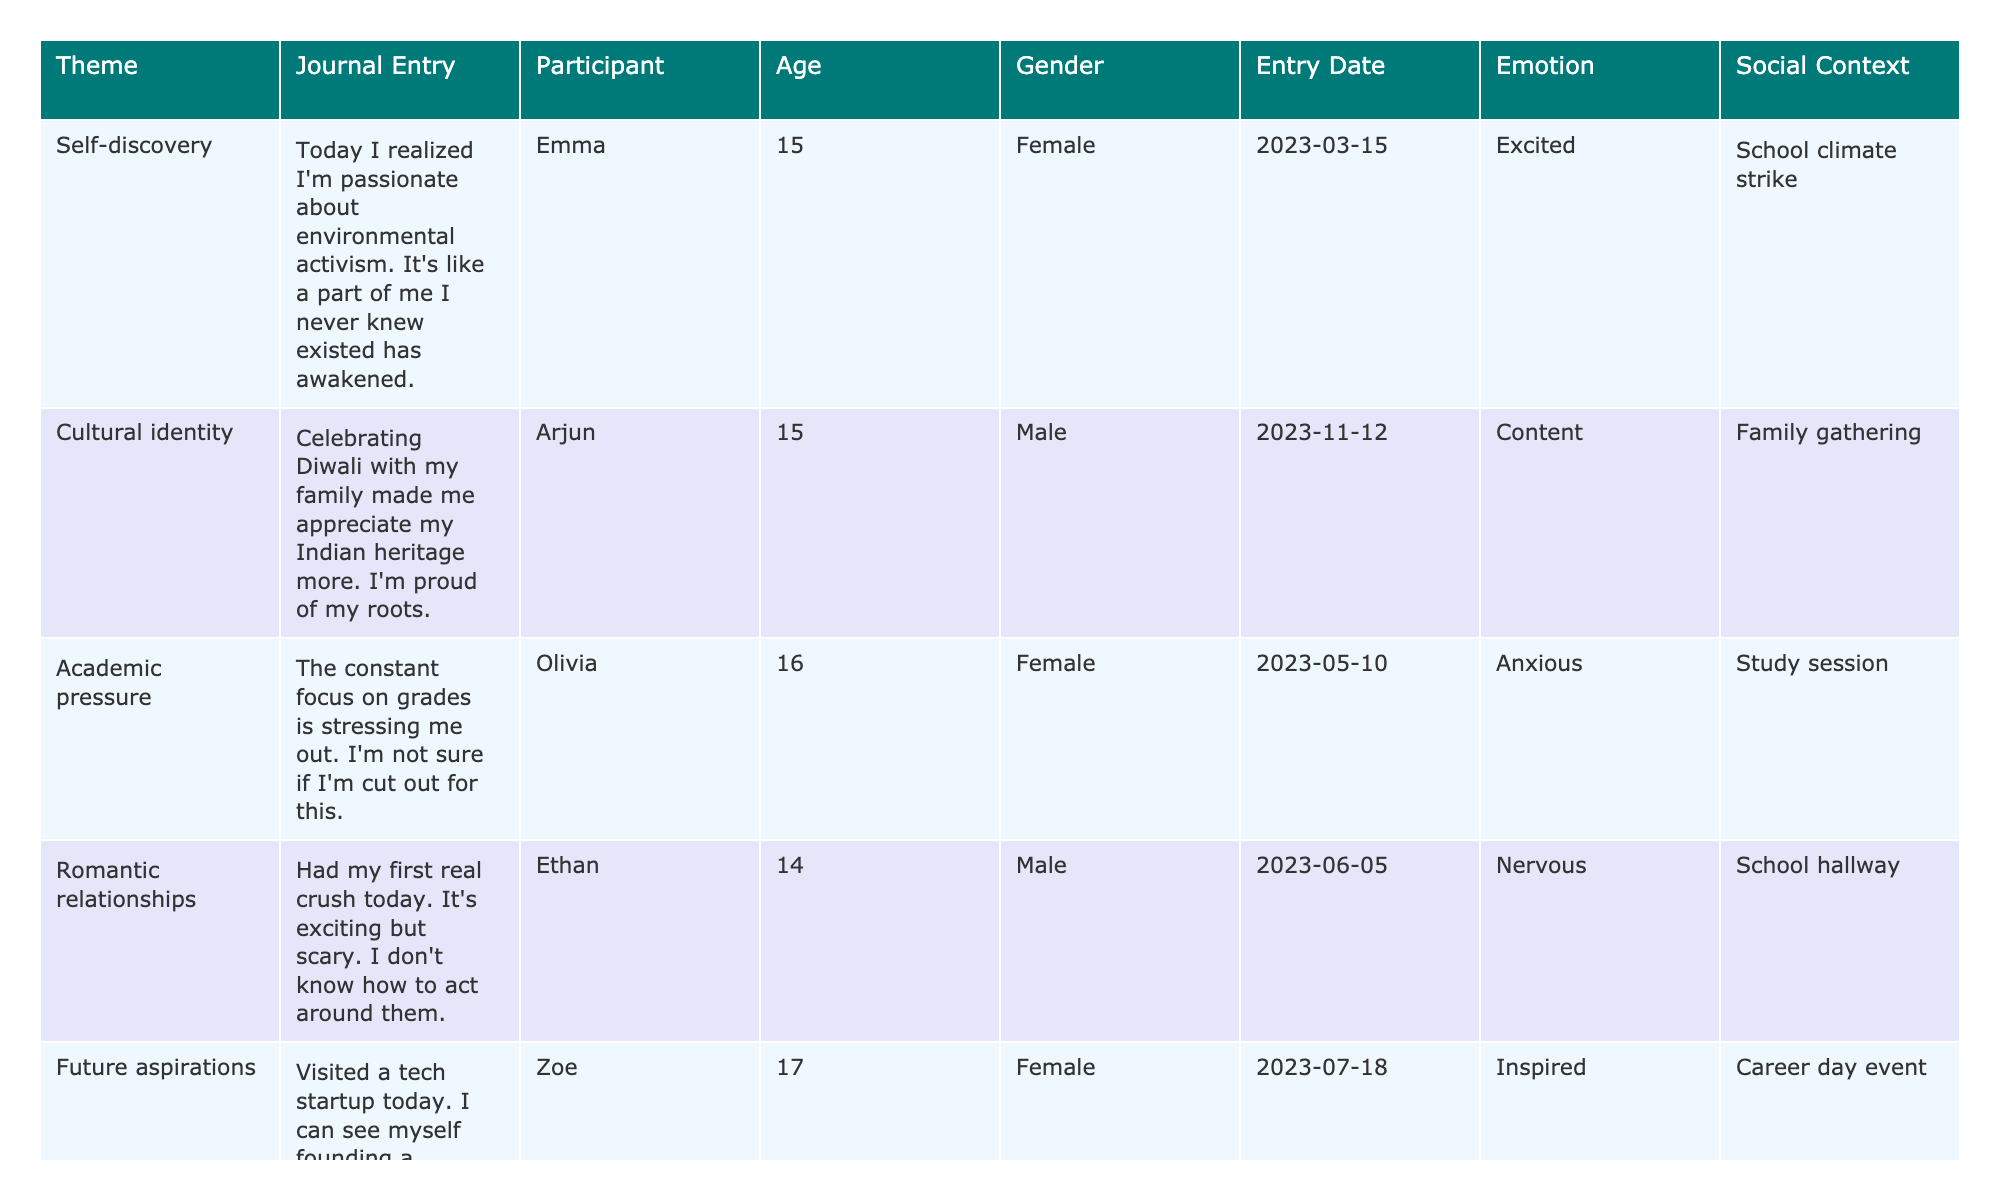What's the theme of Emma's journal entry? Emma's journal entry is under the theme of "Self-discovery." This can be found in the first row of the table.
Answer: Self-discovery How many participants are noted in the table? There are 8 unique journal entries listed in the table, each attributed to a different participant, indicating that there are 8 participants in total.
Answer: 8 Which participant expressed feelings of anxiety regarding academic pressure? Olivia expressed feelings of anxiety related to academic pressure in her journal entry, as indicated in the row labeled "Academic pressure."
Answer: Olivia What emotions are associated with Liam's entry? Liam's entry has the emotion labeled as "Insecure," which can be found in the "Emotion" column next to his name.
Answer: Insecure How many entries mention positive emotions? Looking through the entries, "Excited," "Content," and "Inspired" are considered positive emotions. There are 3 entries with positive emotions: Emma, Arjun, and Zoe.
Answer: 3 Is there a female participant who discussed cultural identity? No, the only entry discussing cultural identity is from Arjun, who is male. Therefore, there are no female participants noted for cultural identity.
Answer: No Which theme has the youngest participant? The theme with the youngest participant, Ethan, is "Romantic relationships," and he is 14 years old. This can be concluded from the table where Ethan is listed first among the entries.
Answer: Romantic relationships What is the average age of the participants in the table? The ages of the participants are 15, 15, 16, 14, 17, 15, 16, and 17. To find the average, add the ages (15 + 15 + 16 + 14 + 17 + 15 + 16 + 17 = 15.875) and divide by 8, which gives approximately 15.875.
Answer: 15.875 What themes are associated with entries from participants aged 17? Both "Future aspirations" and "Moral values" are themes associated with participants aged 17, as listed in the table next to Zoe and Noah.
Answer: Future aspirations, Moral values How many entries mention social media influence? There is only one entry in the table that discusses social media influence. Specifically, the entry from Ava addresses this theme.
Answer: 1 Which emotion is most frequently represented in the table? The emotions mentioned in the table are "Excited," "Content," "Anxious," "Nervous," "Inspired," "Insecure," "Doubtful," and "Reflective." "Excited" is unique among entries, only appearing once, indicating no dominant emotion.
Answer: No dominant emotion 